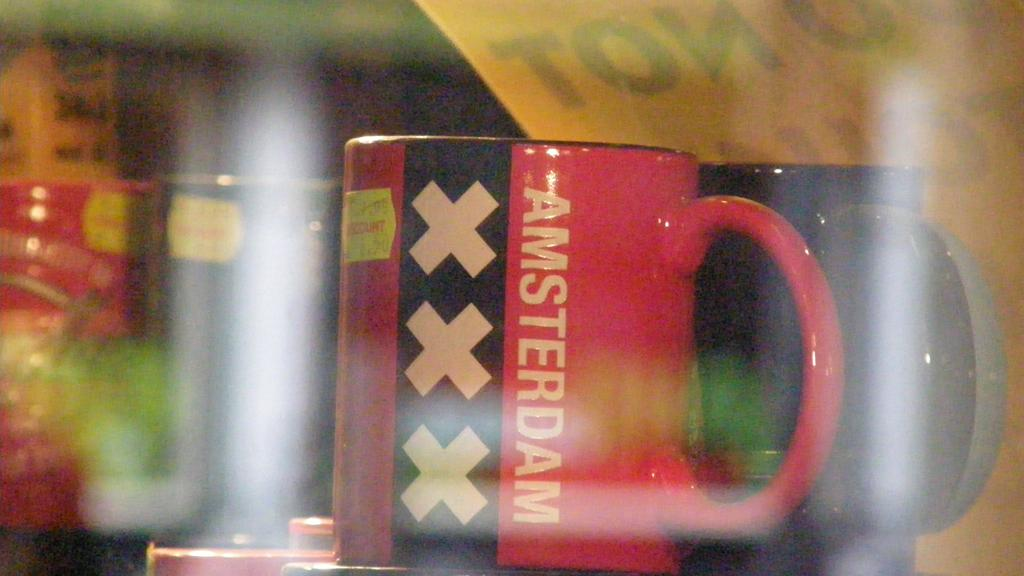<image>
Give a short and clear explanation of the subsequent image. Two coffee mugs one of them red with three X's on it and the word AMSTERDAM. 